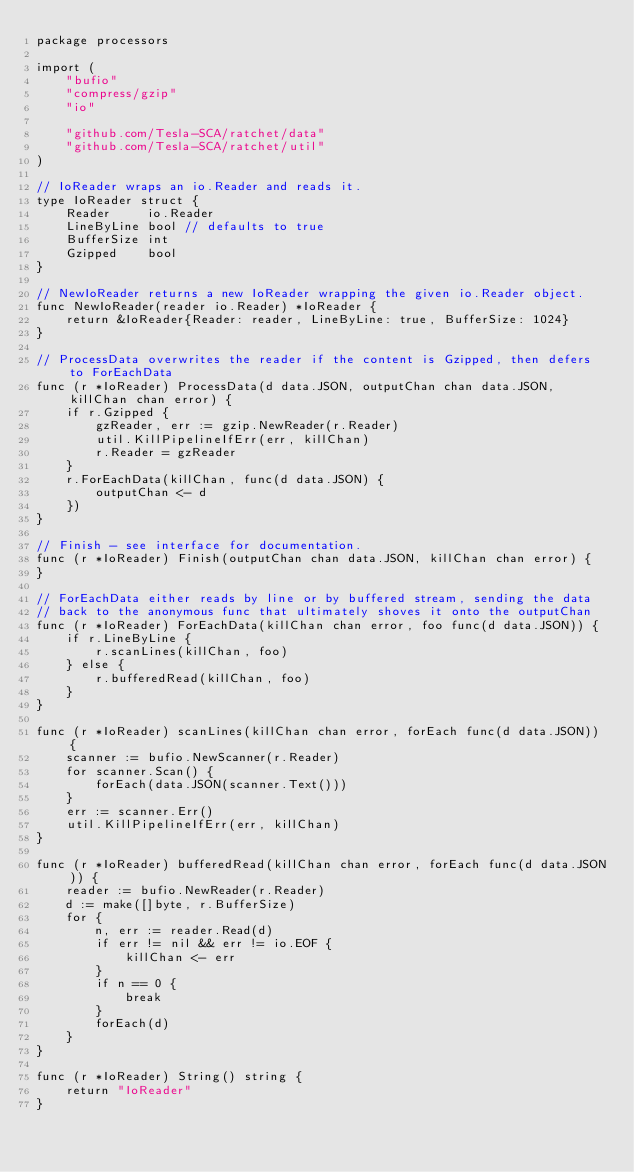<code> <loc_0><loc_0><loc_500><loc_500><_Go_>package processors

import (
	"bufio"
	"compress/gzip"
	"io"

	"github.com/Tesla-SCA/ratchet/data"
	"github.com/Tesla-SCA/ratchet/util"
)

// IoReader wraps an io.Reader and reads it.
type IoReader struct {
	Reader     io.Reader
	LineByLine bool // defaults to true
	BufferSize int
	Gzipped    bool
}

// NewIoReader returns a new IoReader wrapping the given io.Reader object.
func NewIoReader(reader io.Reader) *IoReader {
	return &IoReader{Reader: reader, LineByLine: true, BufferSize: 1024}
}

// ProcessData overwrites the reader if the content is Gzipped, then defers to ForEachData
func (r *IoReader) ProcessData(d data.JSON, outputChan chan data.JSON, killChan chan error) {
	if r.Gzipped {
		gzReader, err := gzip.NewReader(r.Reader)
		util.KillPipelineIfErr(err, killChan)
		r.Reader = gzReader
	}
	r.ForEachData(killChan, func(d data.JSON) {
		outputChan <- d
	})
}

// Finish - see interface for documentation.
func (r *IoReader) Finish(outputChan chan data.JSON, killChan chan error) {
}

// ForEachData either reads by line or by buffered stream, sending the data
// back to the anonymous func that ultimately shoves it onto the outputChan
func (r *IoReader) ForEachData(killChan chan error, foo func(d data.JSON)) {
	if r.LineByLine {
		r.scanLines(killChan, foo)
	} else {
		r.bufferedRead(killChan, foo)
	}
}

func (r *IoReader) scanLines(killChan chan error, forEach func(d data.JSON)) {
	scanner := bufio.NewScanner(r.Reader)
	for scanner.Scan() {
		forEach(data.JSON(scanner.Text()))
	}
	err := scanner.Err()
	util.KillPipelineIfErr(err, killChan)
}

func (r *IoReader) bufferedRead(killChan chan error, forEach func(d data.JSON)) {
	reader := bufio.NewReader(r.Reader)
	d := make([]byte, r.BufferSize)
	for {
		n, err := reader.Read(d)
		if err != nil && err != io.EOF {
			killChan <- err
		}
		if n == 0 {
			break
		}
		forEach(d)
	}
}

func (r *IoReader) String() string {
	return "IoReader"
}
</code> 